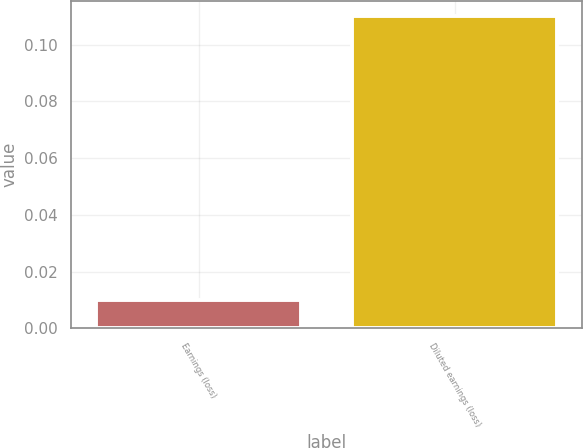Convert chart to OTSL. <chart><loc_0><loc_0><loc_500><loc_500><bar_chart><fcel>Earnings (loss)<fcel>Diluted earnings (loss)<nl><fcel>0.01<fcel>0.11<nl></chart> 